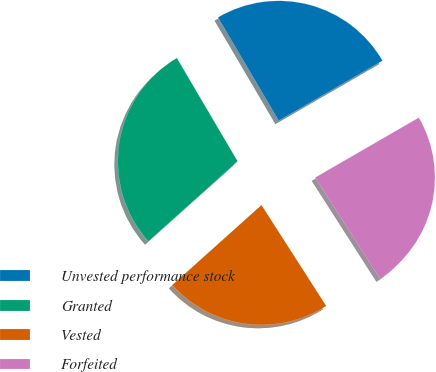Convert chart to OTSL. <chart><loc_0><loc_0><loc_500><loc_500><pie_chart><fcel>Unvested performance stock<fcel>Granted<fcel>Vested<fcel>Forfeited<nl><fcel>25.12%<fcel>28.17%<fcel>22.44%<fcel>24.27%<nl></chart> 